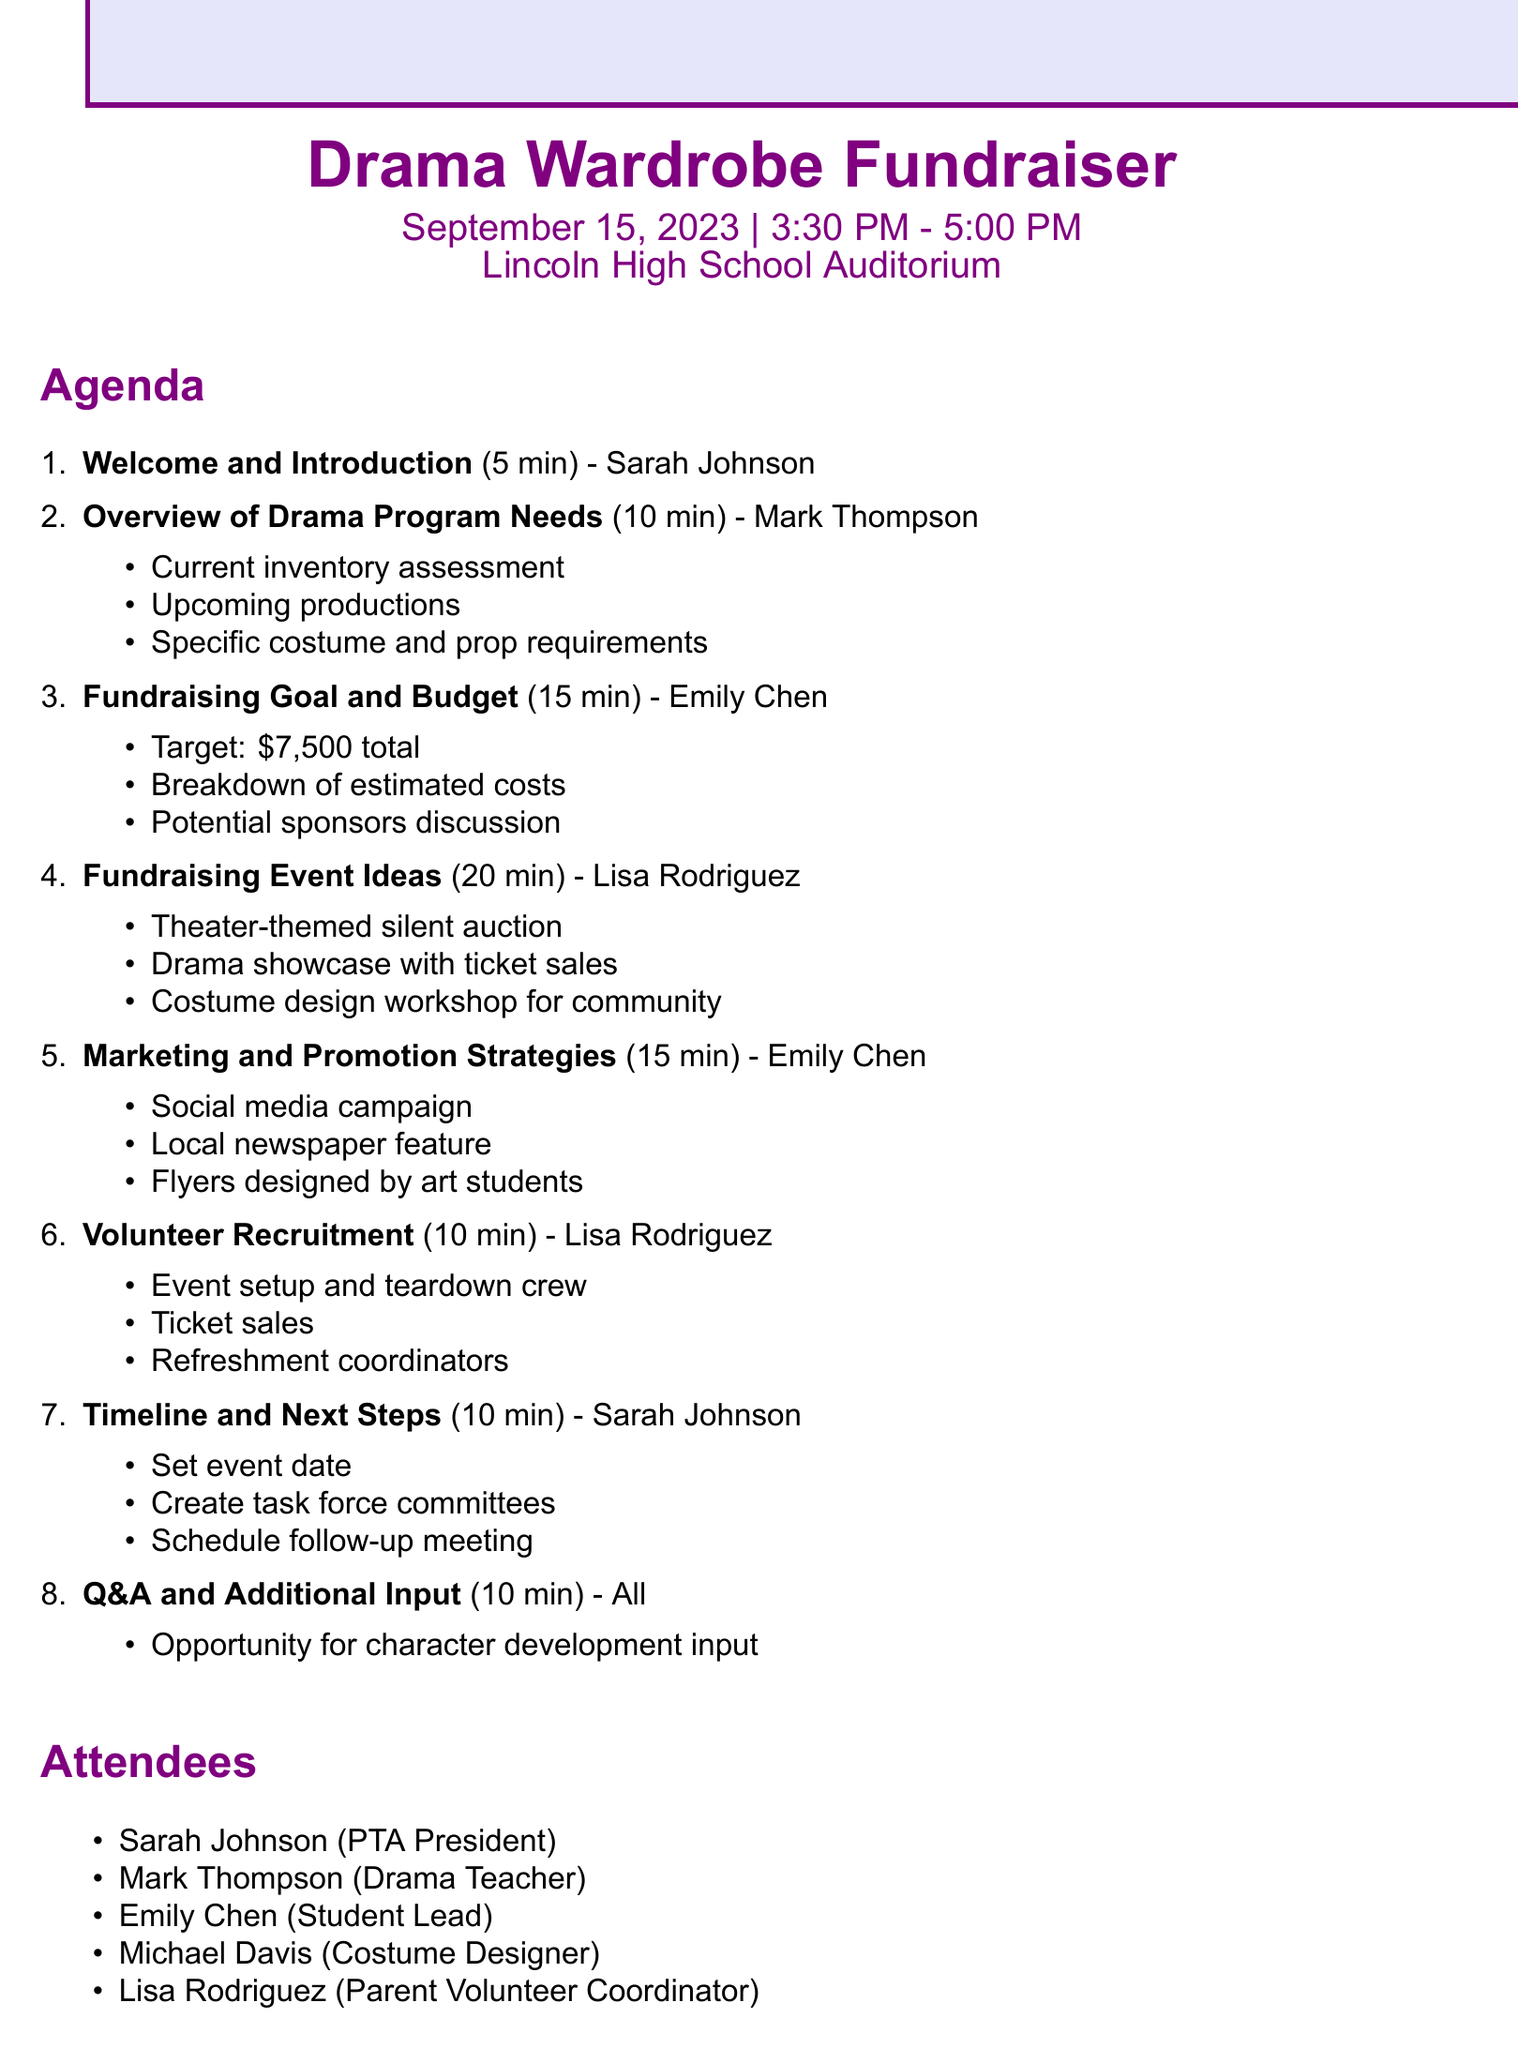What is the name of the fundraising event? The name of the event, as stated in the document, is "Drama Wardrobe Fundraiser".
Answer: Drama Wardrobe Fundraiser What is the date of the event? The document specifies that the event will take place on "September 15, 2023".
Answer: September 15, 2023 Who is leading the "Overview of Drama Program Needs" agenda item? According to the agenda, Mark Thompson is responsible for leading this item.
Answer: Mark Thompson What is the total fundraising goal? The document outlines a target fundraising goal of $7,500 in total for costumes and props.
Answer: $7,500 How long is the "Fundraising Event Ideas" discussion scheduled for? The agenda indicates that this discussion is planned for "20 minutes".
Answer: 20 minutes What roles are needed for volunteer recruitment? The document lists roles including event setup crew, ticket sales, and refreshment coordinators.
Answer: Event setup and teardown crew, Ticket sales, Refreshment coordinators Which two suppliers are discussed as potential sponsors? The document mentions "Spotlight Theater Supply" and "Curtain Call Fabrics" as potential sponsors.
Answer: Spotlight Theater Supply, Curtain Call Fabrics How many attendees are listed in the document? The document lists a total of five attendees involved in the planning session.
Answer: Five 